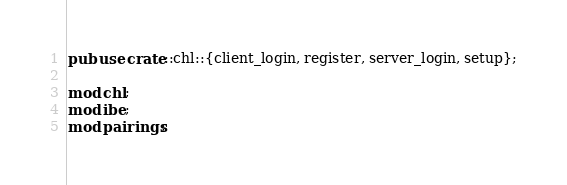Convert code to text. <code><loc_0><loc_0><loc_500><loc_500><_Rust_>pub use crate::chl::{client_login, register, server_login, setup};

mod chl;
mod ibe;
mod pairings;
</code> 